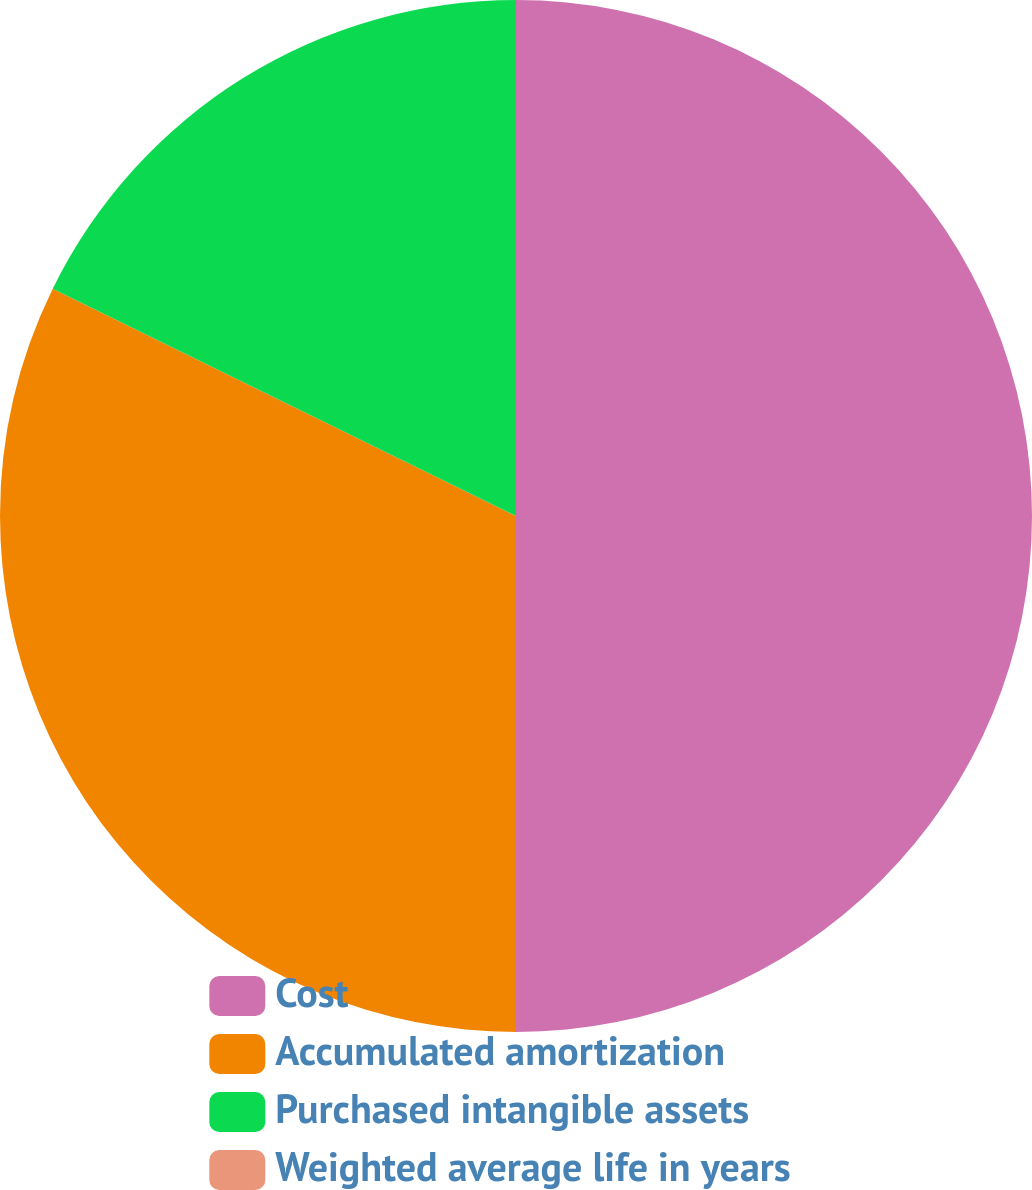Convert chart. <chart><loc_0><loc_0><loc_500><loc_500><pie_chart><fcel>Cost<fcel>Accumulated amortization<fcel>Purchased intangible assets<fcel>Weighted average life in years<nl><fcel>50.0%<fcel>32.26%<fcel>17.74%<fcel>0.0%<nl></chart> 